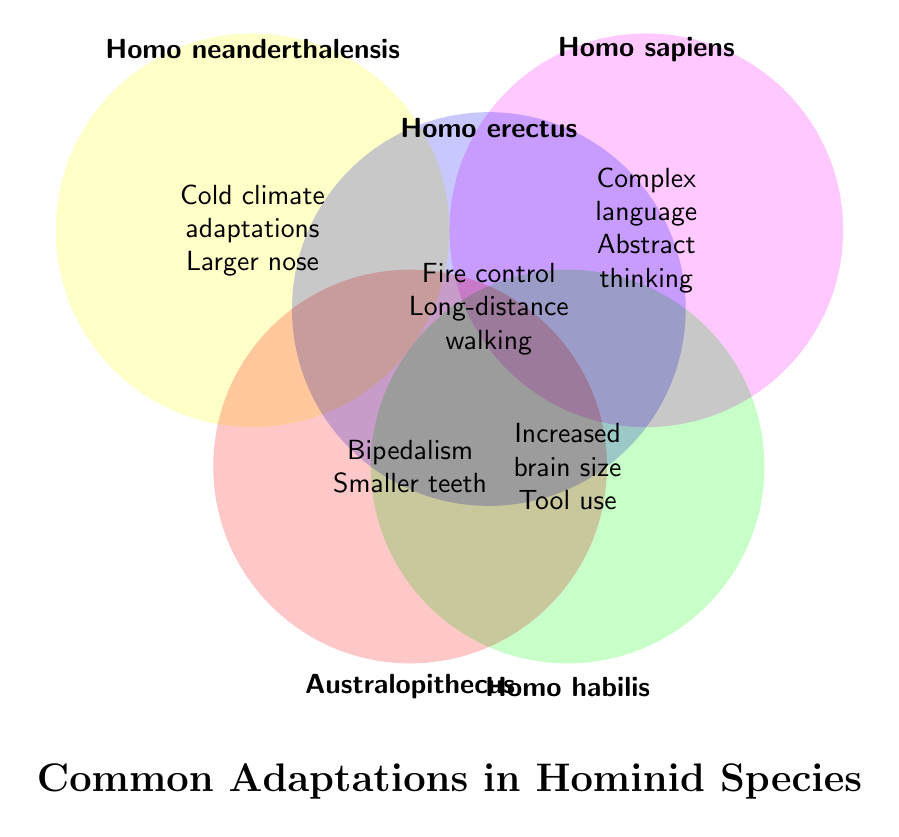What's the title of the Venn Diagram? The title is typically placed prominently on the figure and summarizes what the diagram is about. Here, it's located at the bottom center.
Answer: Common Adaptations in Hominid Species Which hominid species is associated with "Increased brain size"? To find this, look for the adaptation "Increased brain size" in the circles. It's within the circle labeled "Homo habilis".
Answer: Homo habilis What adaptations are associated with Homo erectus? Look at the circle labeled "Homo erectus". Inside this circle, the adaptations listed are "Fire control" and "Long-distance walking".
Answer: Fire control, Long-distance walking Which species has "Complex language" as an adaptation? Find the text "Complex language" within one of the circles. It is located inside the "Homo sapiens" circle.
Answer: Homo sapiens How many adaptations are listed for Australopithecus? Count the adaptations within the circle labeled "Australopithecus". There are two: "Bipedalism" and "Smaller teeth".
Answer: 2 Are there any shared adaptations among the species? Since the Venn Diagram does not show overlapping areas between the circles, it indicates no adaptations are shared among the species in this diagram.
Answer: No Compare the adaptations of Homo neanderthalensis and Homo sapiens. Which adaptations are unique to each? List the adaptations for each and compare. Homo neanderthalensis has "Cold climate adaptations" and "Larger nose", while Homo sapiens has "Complex language" and "Abstract thinking". None are shared.
Answer: Homo neanderthalensis: Cold climate adaptations, Larger nose; Homo sapiens: Complex language, Abstract thinking Which species has the adaptation "Tool use"? Locate "Tool use" in one of the circles. It is within the circle for "Homo habilis".
Answer: Homo habilis What can be inferred about hominid species adaptations to climate change from the diagram? Each hominid species developed distinct adaptations to survive in their respective environments, indicating diverse evolutionary paths influenced by climate change.
Answer: Distinct adaptations Which species showed adaptation to cold climates? Look for the adaptation "Cold climate adaptations". It's within the circle labeled "Homo neanderthalensis".
Answer: Homo neanderthalensis 